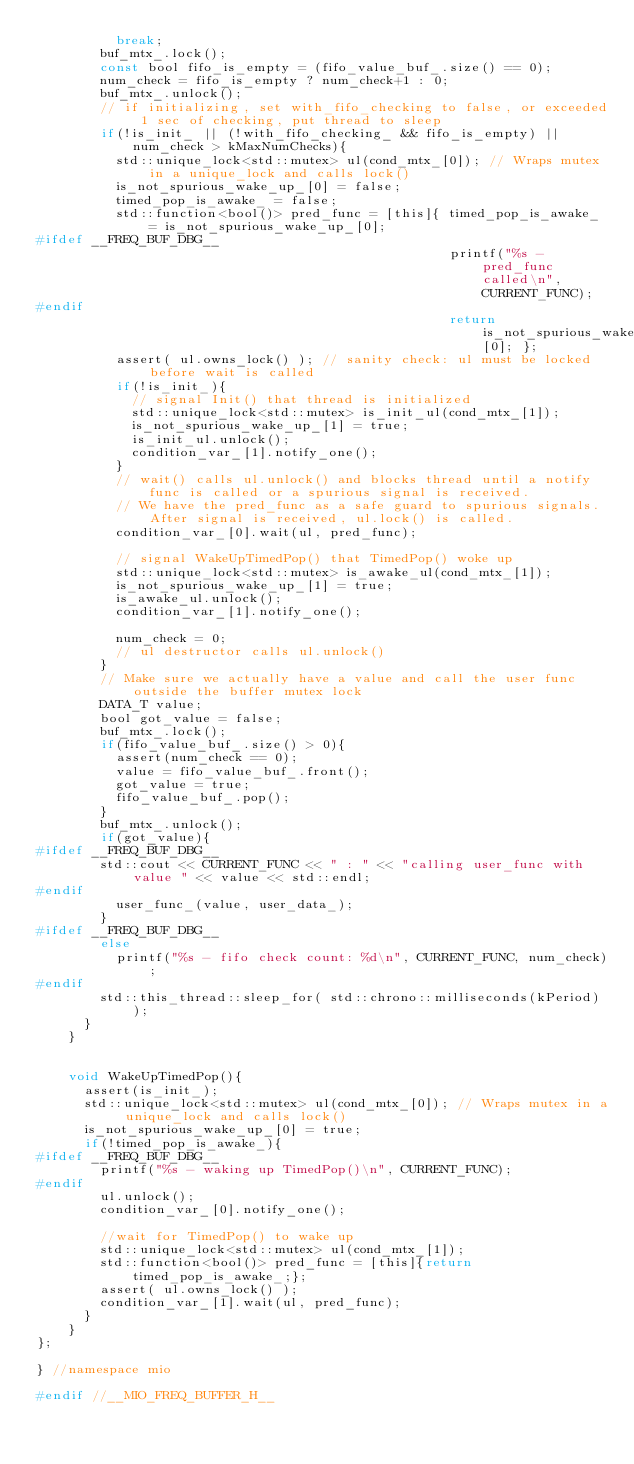Convert code to text. <code><loc_0><loc_0><loc_500><loc_500><_C_>          break;
        buf_mtx_.lock();
        const bool fifo_is_empty = (fifo_value_buf_.size() == 0);
        num_check = fifo_is_empty ? num_check+1 : 0;
        buf_mtx_.unlock();
        // if initializing, set with_fifo_checking to false, or exceeded 1 sec of checking, put thread to sleep
        if(!is_init_ || (!with_fifo_checking_ && fifo_is_empty) || num_check > kMaxNumChecks){
          std::unique_lock<std::mutex> ul(cond_mtx_[0]); // Wraps mutex in a unique_lock and calls lock()
          is_not_spurious_wake_up_[0] = false;
          timed_pop_is_awake_ = false;
          std::function<bool()> pred_func = [this]{ timed_pop_is_awake_ = is_not_spurious_wake_up_[0];
#ifdef __FREQ_BUF_DBG__
                                                    printf("%s - pred_func called\n", CURRENT_FUNC);
#endif
                                                    return is_not_spurious_wake_up_[0]; };
          assert( ul.owns_lock() ); // sanity check: ul must be locked before wait is called
          if(!is_init_){
            // signal Init() that thread is initialized
            std::unique_lock<std::mutex> is_init_ul(cond_mtx_[1]);
            is_not_spurious_wake_up_[1] = true;
            is_init_ul.unlock();
            condition_var_[1].notify_one();
          }
          // wait() calls ul.unlock() and blocks thread until a notify func is called or a spurious signal is received.
          // We have the pred_func as a safe guard to spurious signals. After signal is received, ul.lock() is called.
          condition_var_[0].wait(ul, pred_func);

          // signal WakeUpTimedPop() that TimedPop() woke up
          std::unique_lock<std::mutex> is_awake_ul(cond_mtx_[1]);
          is_not_spurious_wake_up_[1] = true;
          is_awake_ul.unlock();
          condition_var_[1].notify_one();

          num_check = 0;
          // ul destructor calls ul.unlock()
        }
        // Make sure we actually have a value and call the user func outside the buffer mutex lock
        DATA_T value;
        bool got_value = false;
        buf_mtx_.lock();
        if(fifo_value_buf_.size() > 0){
          assert(num_check == 0);
          value = fifo_value_buf_.front();
          got_value = true;
          fifo_value_buf_.pop();
        }
        buf_mtx_.unlock();
        if(got_value){
#ifdef __FREQ_BUF_DBG__
        std::cout << CURRENT_FUNC << " : " << "calling user_func with value " << value << std::endl;
#endif
          user_func_(value, user_data_);
        }
#ifdef __FREQ_BUF_DBG__
        else
          printf("%s - fifo check count: %d\n", CURRENT_FUNC, num_check);
#endif
        std::this_thread::sleep_for( std::chrono::milliseconds(kPeriod) );
      }
    }


    void WakeUpTimedPop(){
      assert(is_init_);
      std::unique_lock<std::mutex> ul(cond_mtx_[0]); // Wraps mutex in a unique_lock and calls lock()
      is_not_spurious_wake_up_[0] = true;
      if(!timed_pop_is_awake_){
#ifdef __FREQ_BUF_DBG__
        printf("%s - waking up TimedPop()\n", CURRENT_FUNC);
#endif
        ul.unlock();
        condition_var_[0].notify_one();

        //wait for TimedPop() to wake up
        std::unique_lock<std::mutex> ul(cond_mtx_[1]);
        std::function<bool()> pred_func = [this]{return timed_pop_is_awake_;};
        assert( ul.owns_lock() );
        condition_var_[1].wait(ul, pred_func);
      }
    }
};

} //namespace mio

#endif //__MIO_FREQ_BUFFER_H__

</code> 